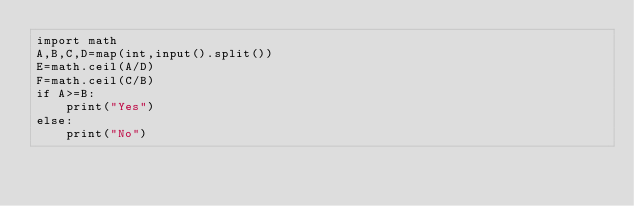<code> <loc_0><loc_0><loc_500><loc_500><_Python_>import math
A,B,C,D=map(int,input().split())
E=math.ceil(A/D)
F=math.ceil(C/B)
if A>=B:
    print("Yes")
else:
    print("No")
</code> 